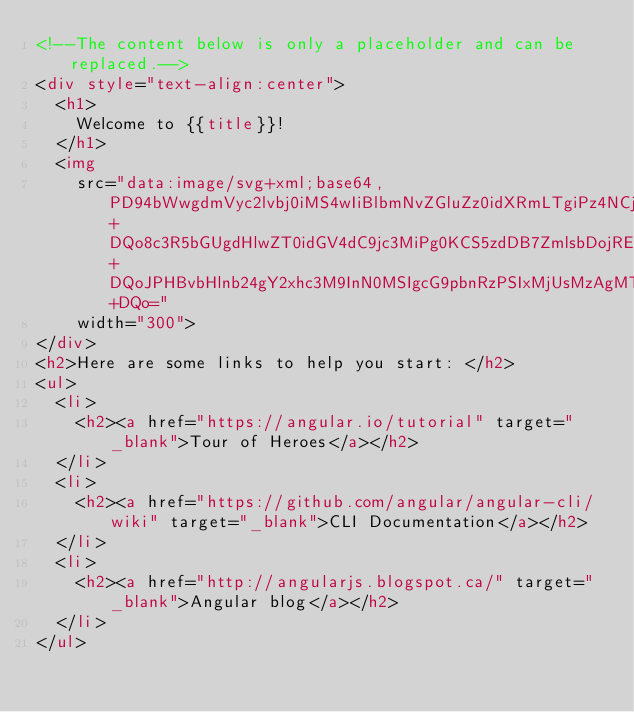<code> <loc_0><loc_0><loc_500><loc_500><_HTML_><!--The content below is only a placeholder and can be replaced.-->
<div style="text-align:center">
  <h1>
    Welcome to {{title}}!
  </h1>
  <img
    src="data:image/svg+xml;base64,PD94bWwgdmVyc2lvbj0iMS4wIiBlbmNvZGluZz0idXRmLTgiPz4NCjwhLS0gR2VuZXJhdG9yOiBBZG9iZSBJbGx1c3RyYXRvciAxOS4xLjAsIFNWRyBFeHBvcnQgUGx1Zy1JbiAuIFNWRyBWZXJzaW9uOiA2LjAwIEJ1aWxkIDApICAtLT4NCjxzdmcgdmVyc2lvbj0iMS4xIiBpZD0iTGF5ZXJfMSIgeG1sbnM9Imh0dHA6Ly93d3cudzMub3JnLzIwMDAvc3ZnIiB4bWxuczp4bGluaz0iaHR0cDovL3d3dy53My5vcmcvMTk5OS94bGluayIgeD0iMHB4IiB5PSIwcHgiDQoJIHZpZXdCb3g9IjAgMCAyNTAgMjUwIiBzdHlsZT0iZW5hYmxlLWJhY2tncm91bmQ6bmV3IDAgMCAyNTAgMjUwOyIgeG1sOnNwYWNlPSJwcmVzZXJ2ZSI+DQo8c3R5bGUgdHlwZT0idGV4dC9jc3MiPg0KCS5zdDB7ZmlsbDojREQwMDMxO30NCgkuc3Qxe2ZpbGw6I0MzMDAyRjt9DQoJLnN0MntmaWxsOiNGRkZGRkY7fQ0KPC9zdHlsZT4NCjxnPg0KCTxwb2x5Z29uIGNsYXNzPSJzdDAiIHBvaW50cz0iMTI1LDMwIDEyNSwzMCAxMjUsMzAgMzEuOSw2My4yIDQ2LjEsMTg2LjMgMTI1LDIzMCAxMjUsMjMwIDEyNSwyMzAgMjAzLjksMTg2LjMgMjE4LjEsNjMuMiAJIi8+DQoJPHBvbHlnb24gY2xhc3M9InN0MSIgcG9pbnRzPSIxMjUsMzAgMTI1LDUyLjIgMTI1LDUyLjEgMTI1LDE1My40IDEyNSwxNTMuNCAxMjUsMjMwIDEyNSwyMzAgMjAzLjksMTg2LjMgMjE4LjEsNjMuMiAxMjUsMzAgCSIvPg0KCTxwYXRoIGNsYXNzPSJzdDIiIGQ9Ik0xMjUsNTIuMUw2Ni44LDE4Mi42aDBoMjEuN2gwbDExLjctMjkuMmg0OS40bDExLjcsMjkuMmgwaDIxLjdoMEwxMjUsNTIuMUwxMjUsNTIuMUwxMjUsNTIuMUwxMjUsNTIuMQ0KCQlMMTI1LDUyLjF6IE0xNDIsMTM1LjRIMTA4bDE3LTQwLjlMMTQyLDEzNS40eiIvPg0KPC9nPg0KPC9zdmc+DQo="
    width="300">
</div>
<h2>Here are some links to help you start: </h2>
<ul>
  <li>
    <h2><a href="https://angular.io/tutorial" target="_blank">Tour of Heroes</a></h2>
  </li>
  <li>
    <h2><a href="https://github.com/angular/angular-cli/wiki" target="_blank">CLI Documentation</a></h2>
  </li>
  <li>
    <h2><a href="http://angularjs.blogspot.ca/" target="_blank">Angular blog</a></h2>
  </li>
</ul>

</code> 